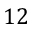Convert formula to latex. <formula><loc_0><loc_0><loc_500><loc_500>1 2</formula> 